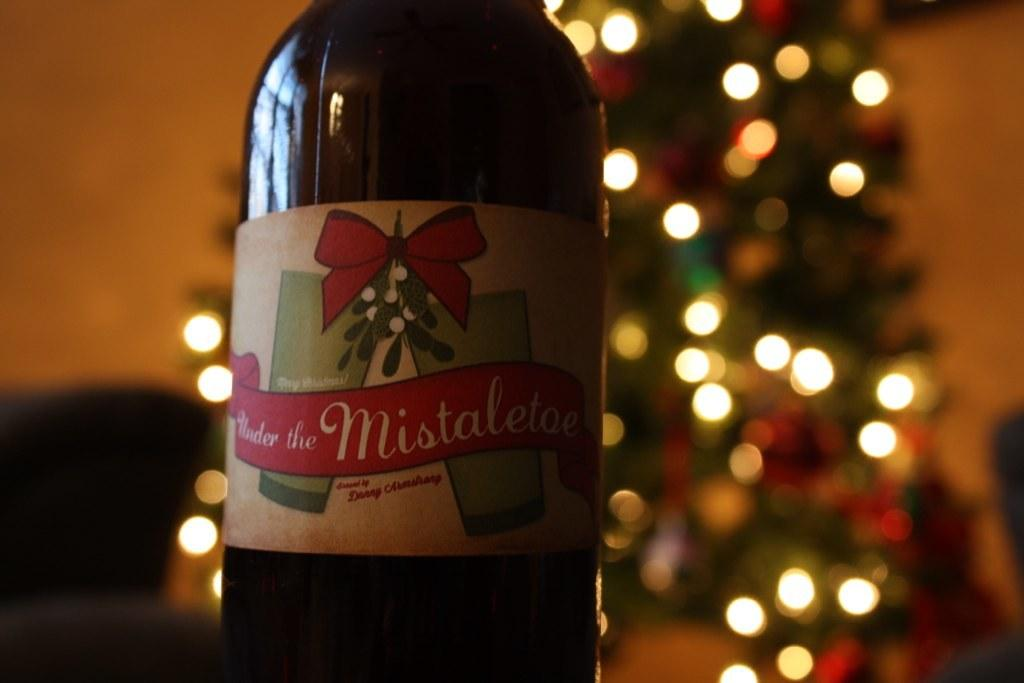What is the main object in the image? There is a wine bottle in the image. Can you describe the background of the image? The background of the image is blurred. How many rings are visible on the wine bottle in the image? There are no rings visible on the wine bottle in the image. What type of fold can be seen in the image? There is no fold present in the image. 